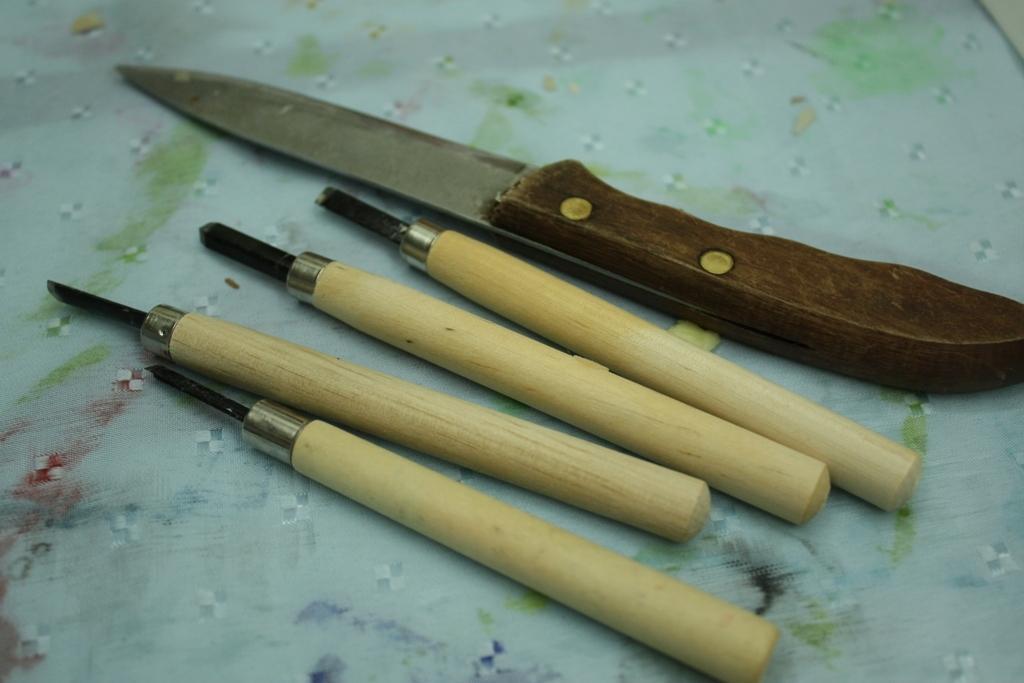Please provide a concise description of this image. In this image we can see a knife and there are some other tools which are placed on the surface which looks like a tablecloth. 